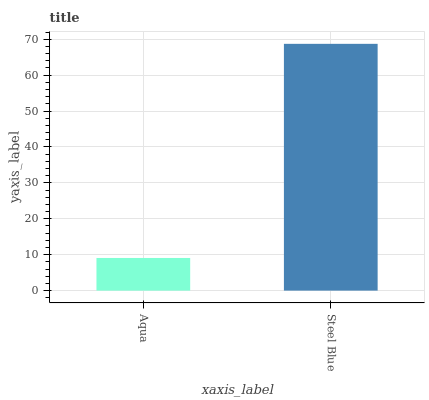Is Steel Blue the minimum?
Answer yes or no. No. Is Steel Blue greater than Aqua?
Answer yes or no. Yes. Is Aqua less than Steel Blue?
Answer yes or no. Yes. Is Aqua greater than Steel Blue?
Answer yes or no. No. Is Steel Blue less than Aqua?
Answer yes or no. No. Is Steel Blue the high median?
Answer yes or no. Yes. Is Aqua the low median?
Answer yes or no. Yes. Is Aqua the high median?
Answer yes or no. No. Is Steel Blue the low median?
Answer yes or no. No. 